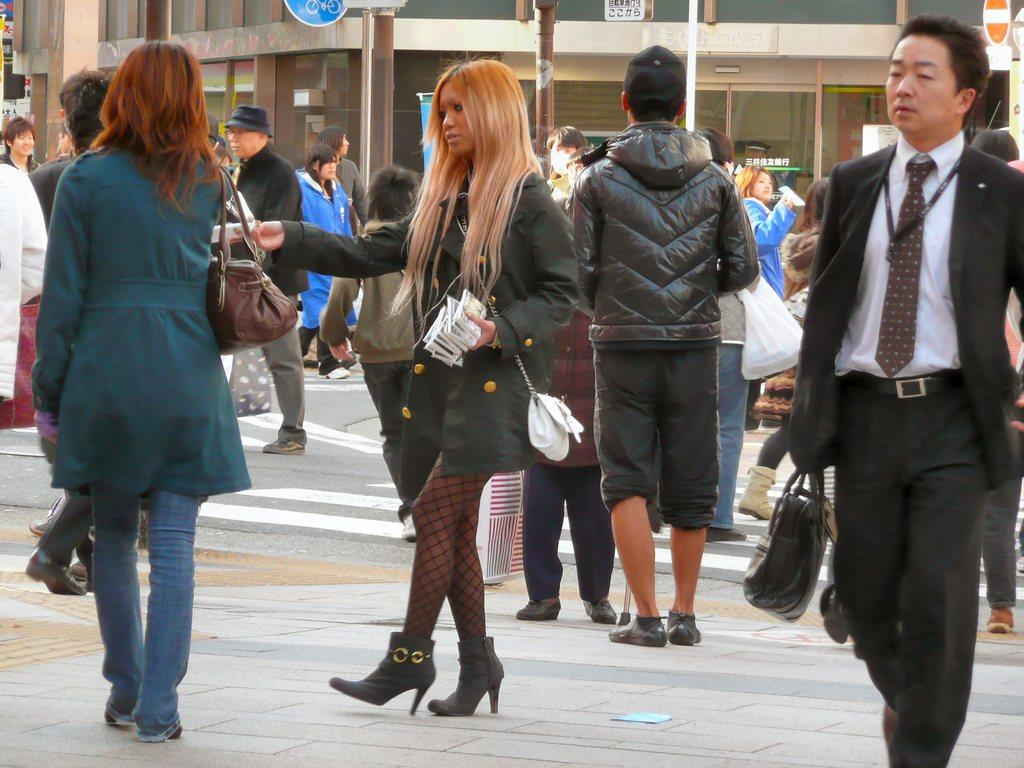How many people are in the image? There is a group of people in the image, but the exact number is not specified. What is the position of the people in the image? The people are on the ground in the image. What can be seen in the distance behind the people? There is a building and objects visible in the background of the image. What type of sticks are the people using to play in the afternoon? There is no indication of sticks or an afternoon playtime in the image. 